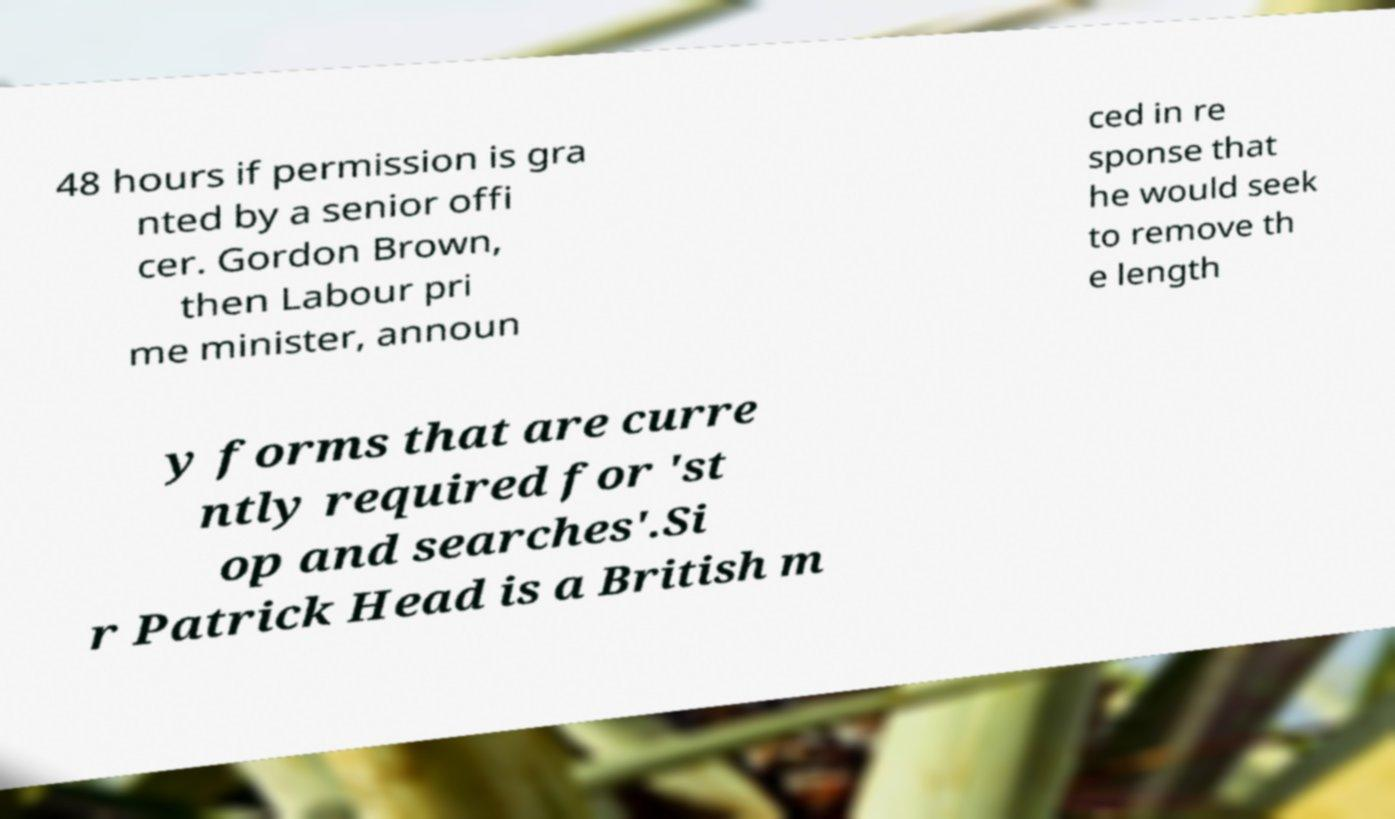Can you accurately transcribe the text from the provided image for me? 48 hours if permission is gra nted by a senior offi cer. Gordon Brown, then Labour pri me minister, announ ced in re sponse that he would seek to remove th e length y forms that are curre ntly required for 'st op and searches'.Si r Patrick Head is a British m 